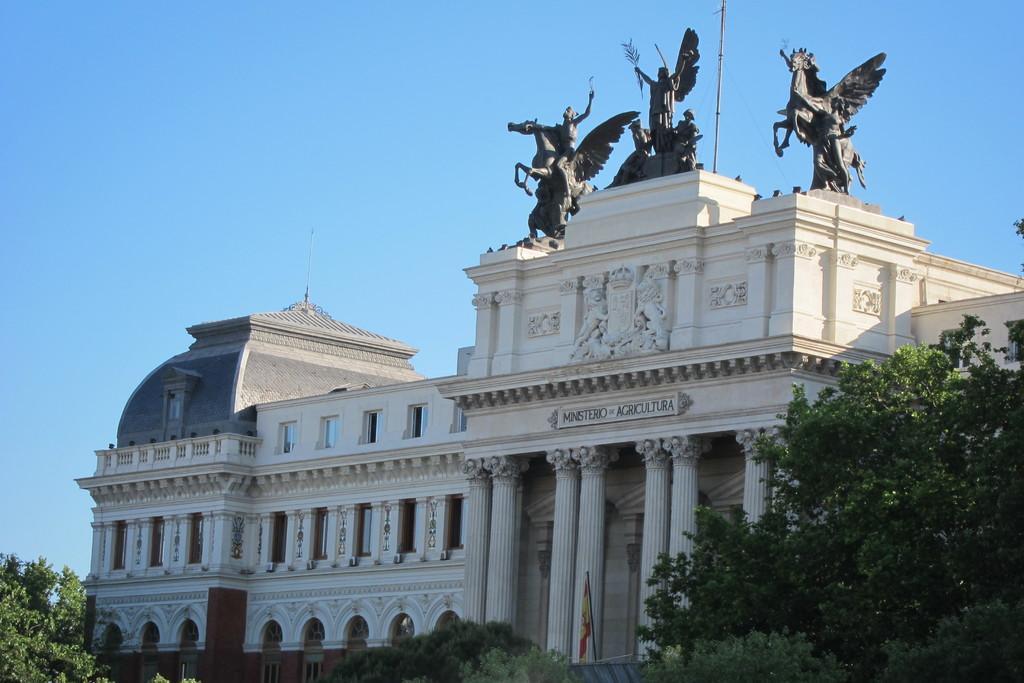In one or two sentences, can you explain what this image depicts? In this picture we can see a building, there are some trees at the bottom, we can see statues and the sky at the top of the picture. 